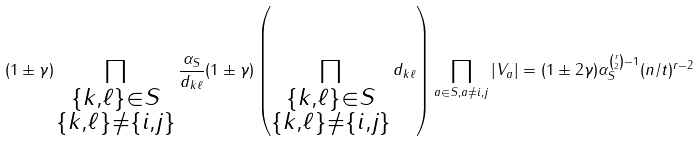<formula> <loc_0><loc_0><loc_500><loc_500>( 1 \pm \gamma ) \prod _ { \substack { \{ k , \ell \} \in S \\ \{ k , \ell \} \neq \{ i , j \} } } \frac { \alpha _ { S } } { d _ { k \ell } } ( 1 \pm \gamma ) \left ( \prod _ { \substack { \{ k , \ell \} \in S \\ \{ k , \ell \} \neq \{ i , j \} } } d _ { k \ell } \right ) \prod _ { a \in S , a \neq i , j } | V _ { a } | = ( 1 \pm 2 \gamma ) \alpha _ { S } ^ { \binom { r } { 2 } - 1 } ( n / t ) ^ { r - 2 }</formula> 